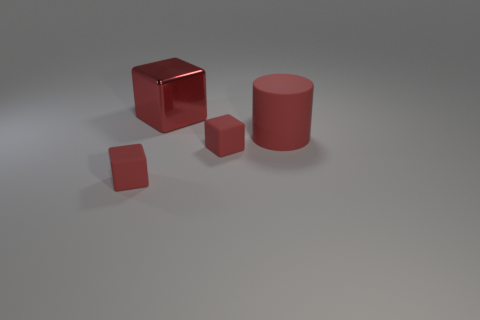What is the material of the other red thing that is the same size as the red shiny thing?
Ensure brevity in your answer.  Rubber. What shape is the matte thing that is both in front of the big red rubber cylinder and on the right side of the big red shiny cube?
Keep it short and to the point. Cube. The cylinder that is the same size as the red metallic cube is what color?
Your response must be concise. Red. Does the red object that is behind the red rubber cylinder have the same size as the red rubber block that is on the right side of the red metal cube?
Make the answer very short. No. There is a shiny thing that is behind the rubber block that is on the left side of the small matte object on the right side of the red shiny object; how big is it?
Give a very brief answer. Large. What is the shape of the big red object right of the big thing on the left side of the large red matte object?
Offer a very short reply. Cylinder. There is a big object that is to the left of the big cylinder; does it have the same color as the large matte thing?
Your answer should be very brief. Yes. The rubber thing that is on the right side of the large red metallic thing and on the left side of the big cylinder is what color?
Your answer should be very brief. Red. Are there any large red objects that have the same material as the red cylinder?
Your answer should be compact. No. How big is the rubber cylinder?
Your answer should be very brief. Large. 